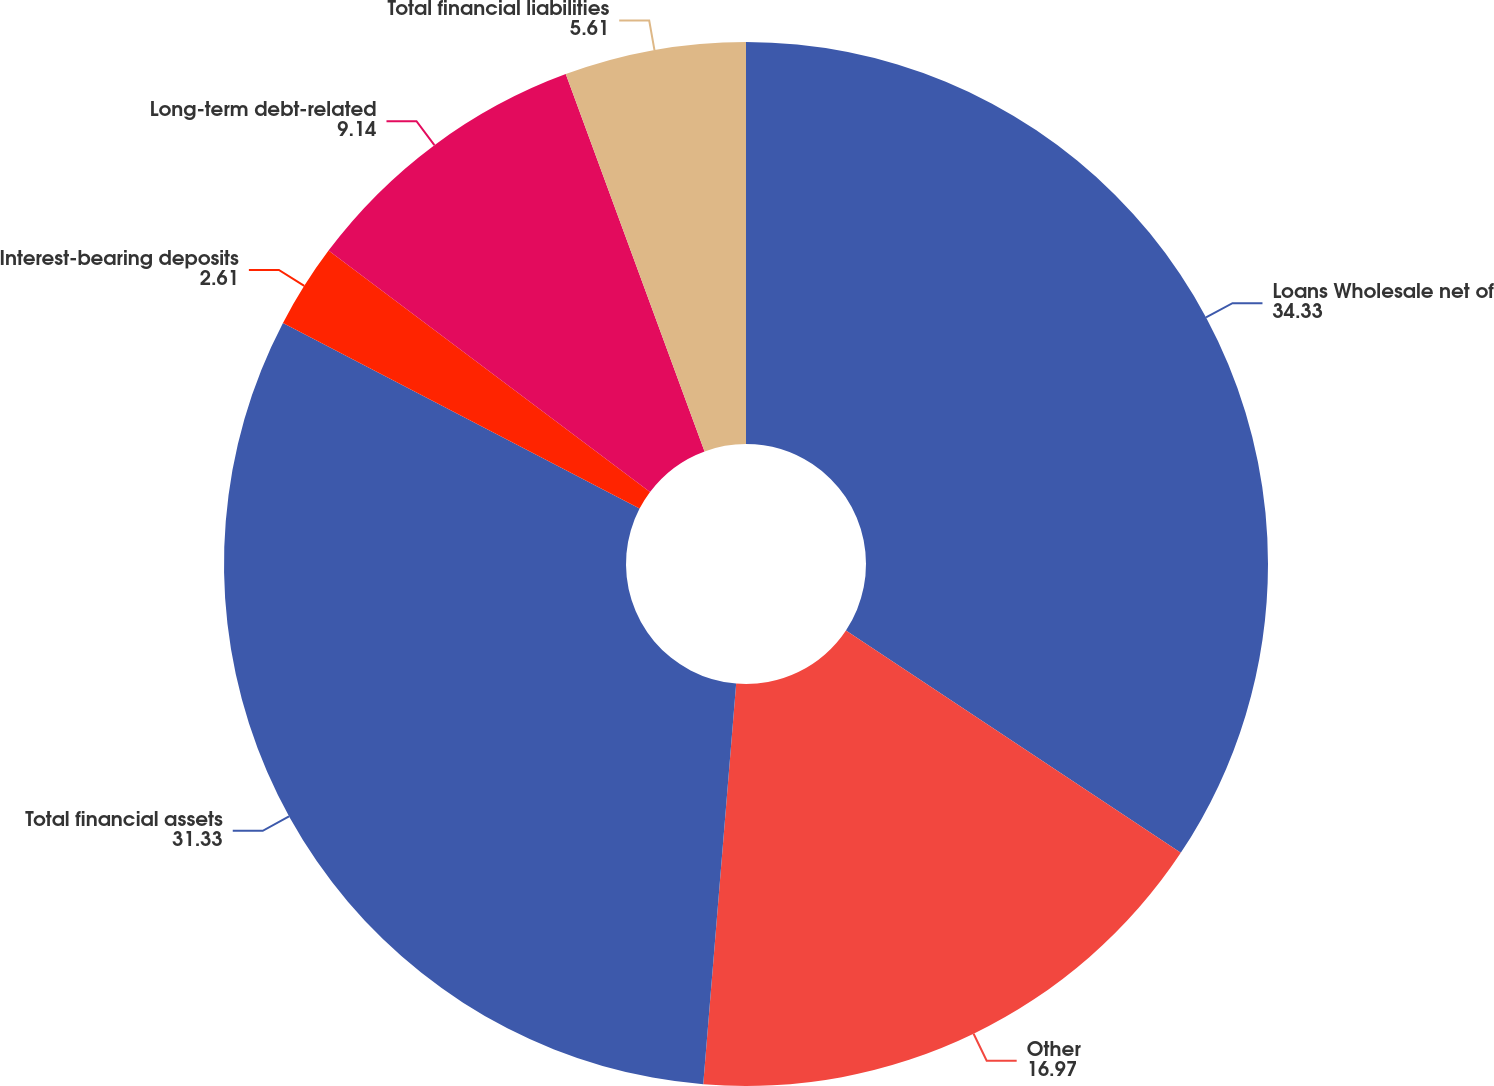<chart> <loc_0><loc_0><loc_500><loc_500><pie_chart><fcel>Loans Wholesale net of<fcel>Other<fcel>Total financial assets<fcel>Interest-bearing deposits<fcel>Long-term debt-related<fcel>Total financial liabilities<nl><fcel>34.33%<fcel>16.97%<fcel>31.33%<fcel>2.61%<fcel>9.14%<fcel>5.61%<nl></chart> 